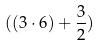Convert formula to latex. <formula><loc_0><loc_0><loc_500><loc_500>( ( 3 \cdot 6 ) + \frac { 3 } { 2 } )</formula> 